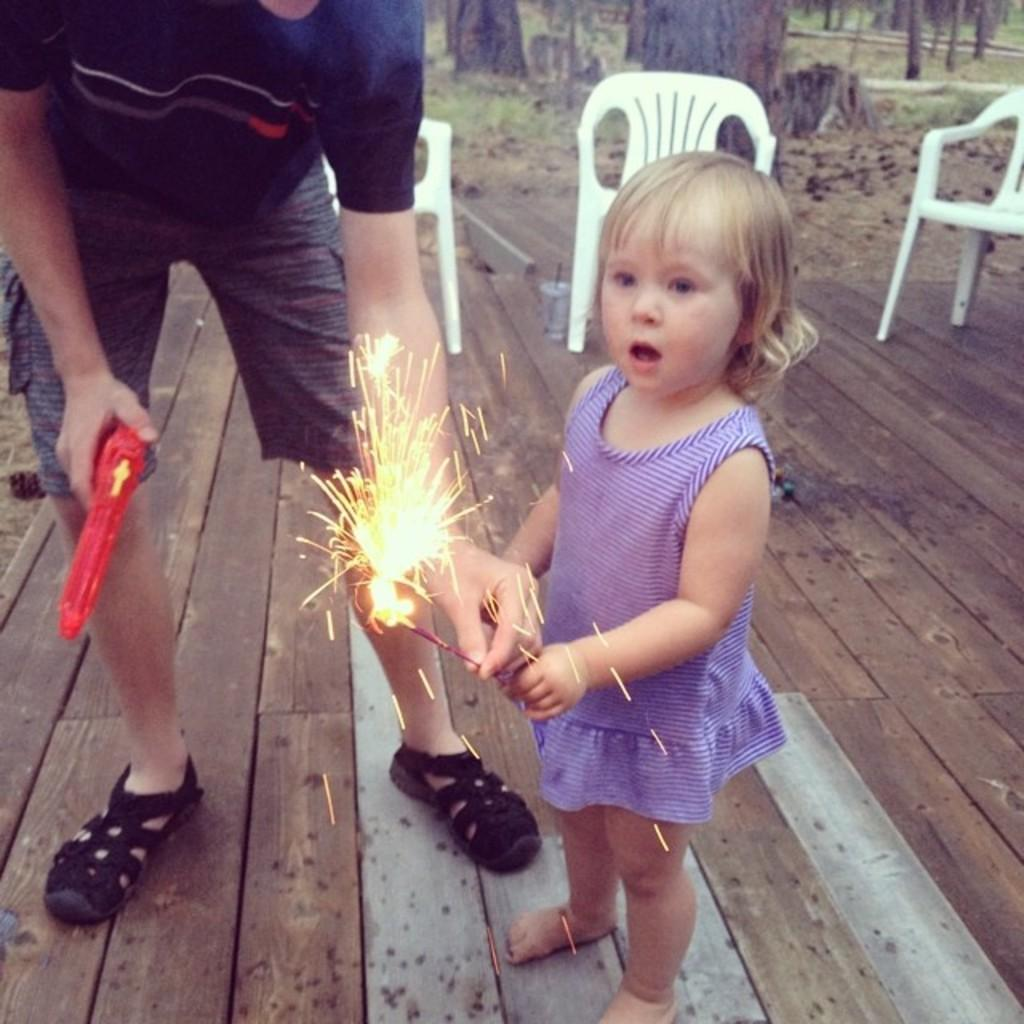Who is the main subject in the image? There is a girl in the image. What is the girl doing in the image? The girl is playing with crackers. What can be seen in the background of the image? There are trees and tree chairs in the background of the image. Who else is present in the image? There is a man on the left side of the image. What is the man holding in his right hand? The man is holding a gun in his right hand. What type of cook is present in the image? There is no cook present in the image. What order is the girl following while playing with the crackers? The image does not show the girl following any specific order while playing with the crackers. 